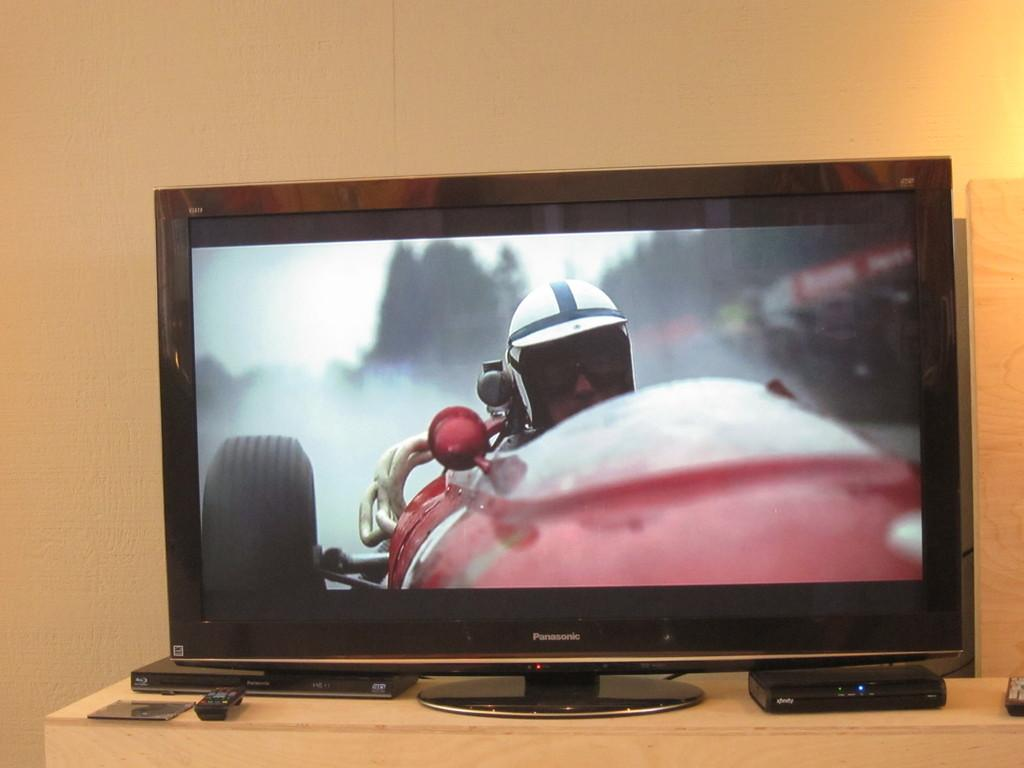Where was the image taken? The image was taken indoors. What can be seen in the background of the image? There is a wall in the background of the image. What is located at the bottom of the image? There is a table at the bottom of the image. What items are on the table? There are two remotes, a device, and a television on the table. How many sisters are visible in the image? There are no sisters present in the image. Can you see the ocean in the background of the image? The image was taken indoors, so the ocean is not visible in the background. 